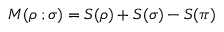Convert formula to latex. <formula><loc_0><loc_0><loc_500><loc_500>M ( \rho \, ; \sigma ) = S ( \rho ) + S ( \sigma ) - S ( \pi )</formula> 